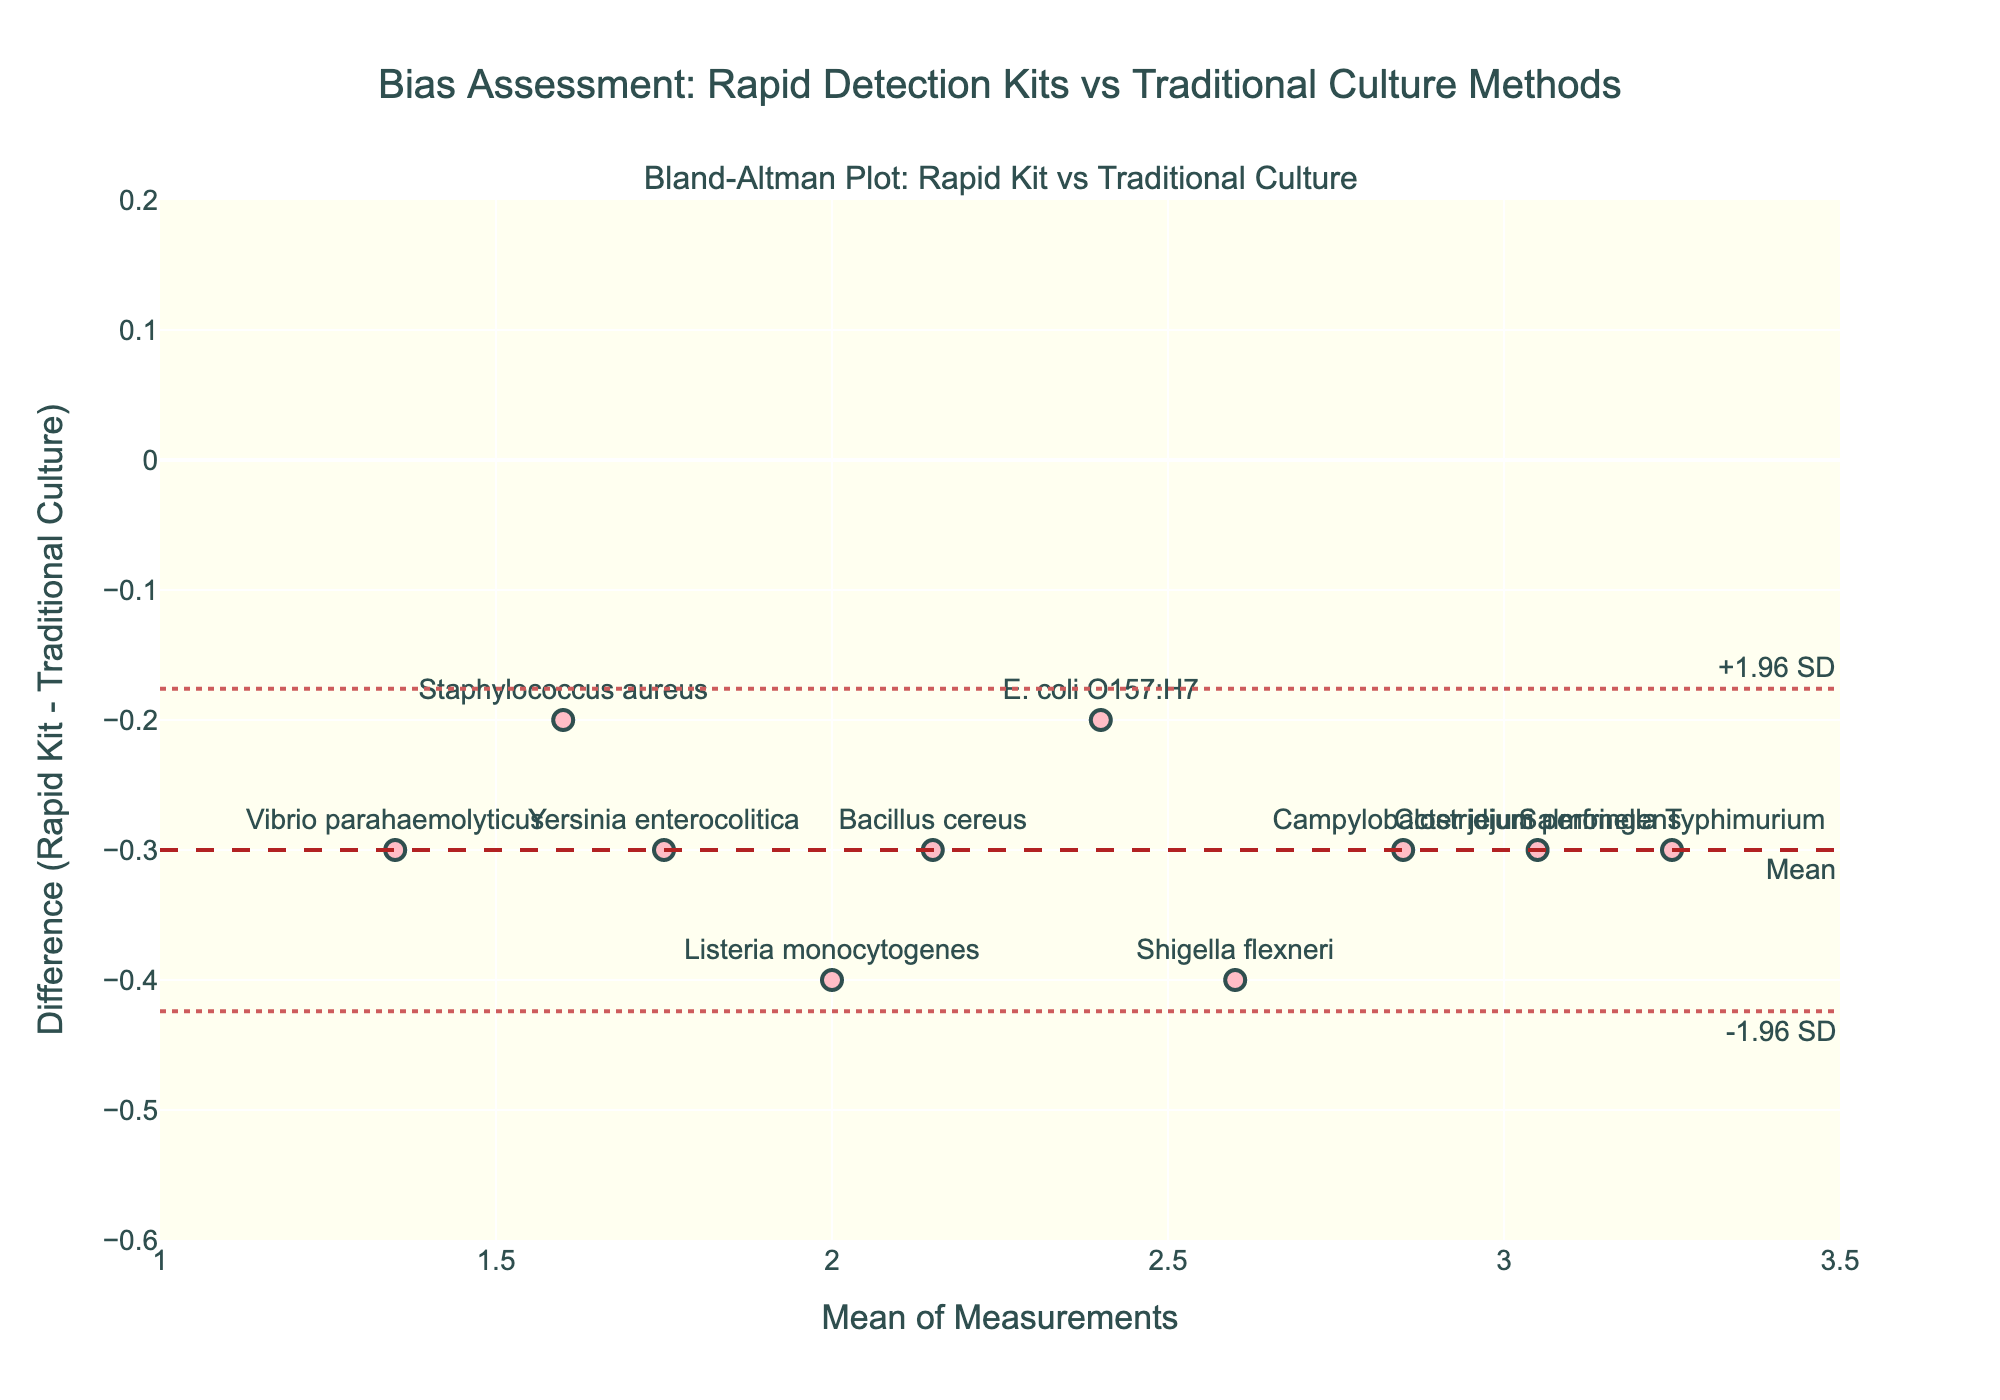Which method has the highest value? The method with the highest value is identified by the point farthest right on the x-axis, representing the mean value. In this case, "Salmonella Typhimurium" has a mean value of approximately 3.25, which is the highest among the data points.
Answer: Salmonella Typhimurium What is the color of the markers used in the plot? The color of the markers can be observed directly from the visual appearance of the plot. In this case, the markers are a shade of pink.
Answer: Pink How many data points are plotted in the figure? Count the number of individual markers present on the plot, each representing one method. There are 10 data points in total.
Answer: 10 What is the mean difference between the Rapid Kit and Traditional Culture methods? The mean difference line is annotated on the y-axis and represented by a dashed line. The annotation says 'Mean' and is positioned around -0.2.
Answer: -0.2 What are the limits of agreement in the plot? The limits of agreement are indicated by the dotted lines and are annotated as '-1.96 SD' and '+1.96 SD'. The limits are around -0.52 and -0.12 respectively.
Answer: -0.52 and -0.12 Which method shows the largest positive difference between the Rapid Kit and Traditional Culture methods? The largest positive difference is identified by the highest point on the y-axis. "Listeria monocytogenes" has the highest point, with a difference of 0.4.
Answer: Listeria monocytogenes Which method presents the smallest difference between Rapid Kit and Traditional Culture methods? The smallest difference is identified by the point closest to the horizontal axis. "Bacillus cereus" shows the smallest difference, around -0.3.
Answer: Bacillus cereus What is the relationship between the mean value and differences observed in the plot? To assess this, observe the trend of the points in relation to the mean values on the x-axis and the differences on the y-axis. Points do not show a clear pattern, suggesting no relationship between mean values and differences.
Answer: No clear relationship Are all the data points within the limits of agreement? Check if all points fall within the horizontal lines of -0.52 and -0.12 on the y-axis. All data points do fall within these limits.
Answer: Yes 